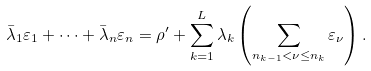Convert formula to latex. <formula><loc_0><loc_0><loc_500><loc_500>\bar { \lambda } _ { 1 } \varepsilon _ { 1 } + \cdots + \bar { \lambda } _ { n } \varepsilon _ { n } = \rho ^ { \prime } + \sum _ { k = 1 } ^ { L } \lambda _ { k } \left ( \sum _ { n _ { k - 1 } < \nu \leq n _ { k } } \varepsilon _ { \nu } \right ) .</formula> 